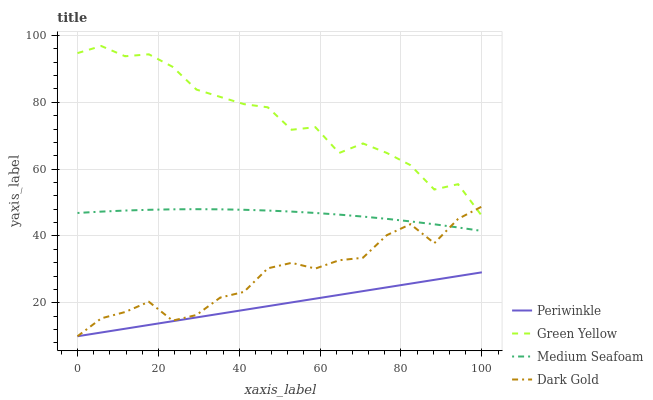Does Periwinkle have the minimum area under the curve?
Answer yes or no. Yes. Does Green Yellow have the maximum area under the curve?
Answer yes or no. Yes. Does Medium Seafoam have the minimum area under the curve?
Answer yes or no. No. Does Medium Seafoam have the maximum area under the curve?
Answer yes or no. No. Is Periwinkle the smoothest?
Answer yes or no. Yes. Is Green Yellow the roughest?
Answer yes or no. Yes. Is Medium Seafoam the smoothest?
Answer yes or no. No. Is Medium Seafoam the roughest?
Answer yes or no. No. Does Periwinkle have the lowest value?
Answer yes or no. Yes. Does Medium Seafoam have the lowest value?
Answer yes or no. No. Does Green Yellow have the highest value?
Answer yes or no. Yes. Does Medium Seafoam have the highest value?
Answer yes or no. No. Is Medium Seafoam less than Green Yellow?
Answer yes or no. Yes. Is Green Yellow greater than Medium Seafoam?
Answer yes or no. Yes. Does Periwinkle intersect Dark Gold?
Answer yes or no. Yes. Is Periwinkle less than Dark Gold?
Answer yes or no. No. Is Periwinkle greater than Dark Gold?
Answer yes or no. No. Does Medium Seafoam intersect Green Yellow?
Answer yes or no. No. 